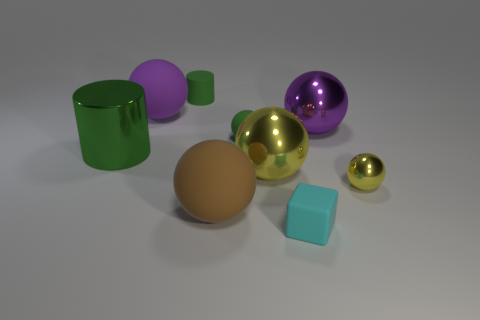Subtract all purple balls. How many balls are left? 4 Subtract all big purple balls. How many balls are left? 4 Subtract all red spheres. Subtract all yellow cylinders. How many spheres are left? 6 Add 1 tiny yellow shiny objects. How many objects exist? 10 Subtract all cylinders. How many objects are left? 7 Subtract all rubber blocks. Subtract all green shiny cylinders. How many objects are left? 7 Add 6 small yellow metallic spheres. How many small yellow metallic spheres are left? 7 Add 4 big purple rubber objects. How many big purple rubber objects exist? 5 Subtract 0 blue blocks. How many objects are left? 9 